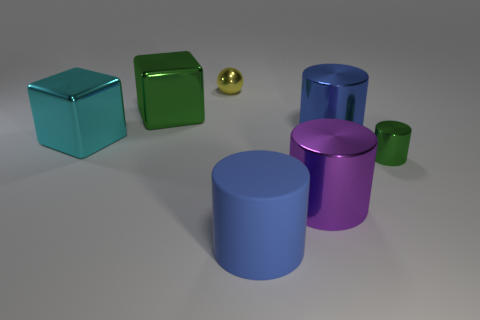Add 2 large green objects. How many objects exist? 9 Subtract all cubes. How many objects are left? 5 Subtract all tiny yellow shiny spheres. Subtract all small red shiny cubes. How many objects are left? 6 Add 4 big cyan cubes. How many big cyan cubes are left? 5 Add 6 small green objects. How many small green objects exist? 7 Subtract 0 gray balls. How many objects are left? 7 